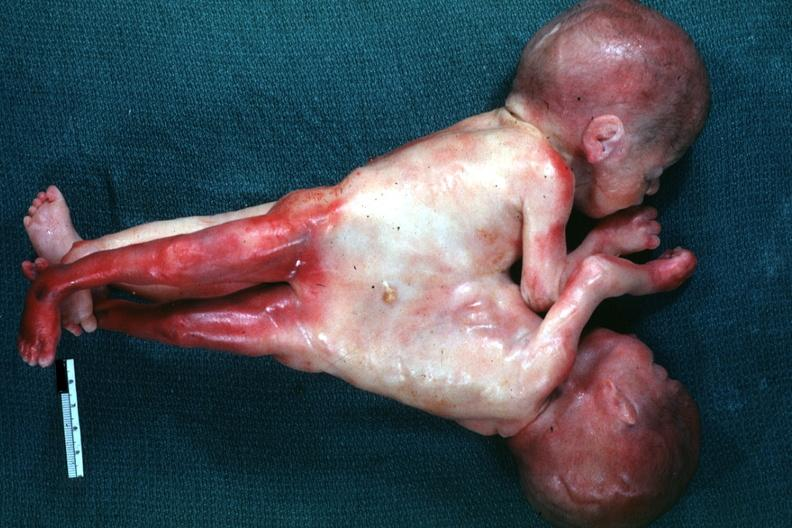s siamese twins present?
Answer the question using a single word or phrase. Yes 